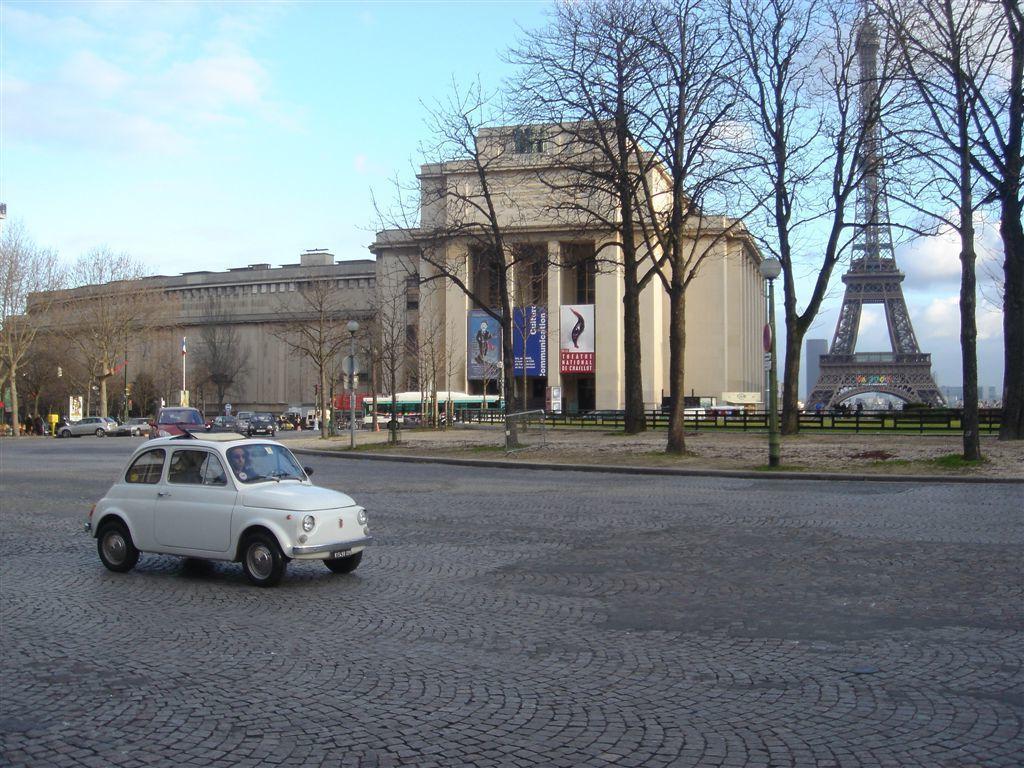In one or two sentences, can you explain what this image depicts? At the bottom of the picture, we see the road. We see a white car is moving on the road. On the right side, we see the trees, light poles and wooden fence. Behind that, we see an Eiffel tower. Beside that, we see the building, poles and the boards in white and blue color with some text written on it. Beside that, we see a building. On the left side, we see the trees, poles and a white color board. At the top, we see the sky and the clouds. 